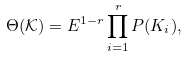Convert formula to latex. <formula><loc_0><loc_0><loc_500><loc_500>\Theta ( \mathcal { K } ) = E ^ { 1 - r } \prod _ { i = 1 } ^ { r } P ( K _ { i } ) ,</formula> 